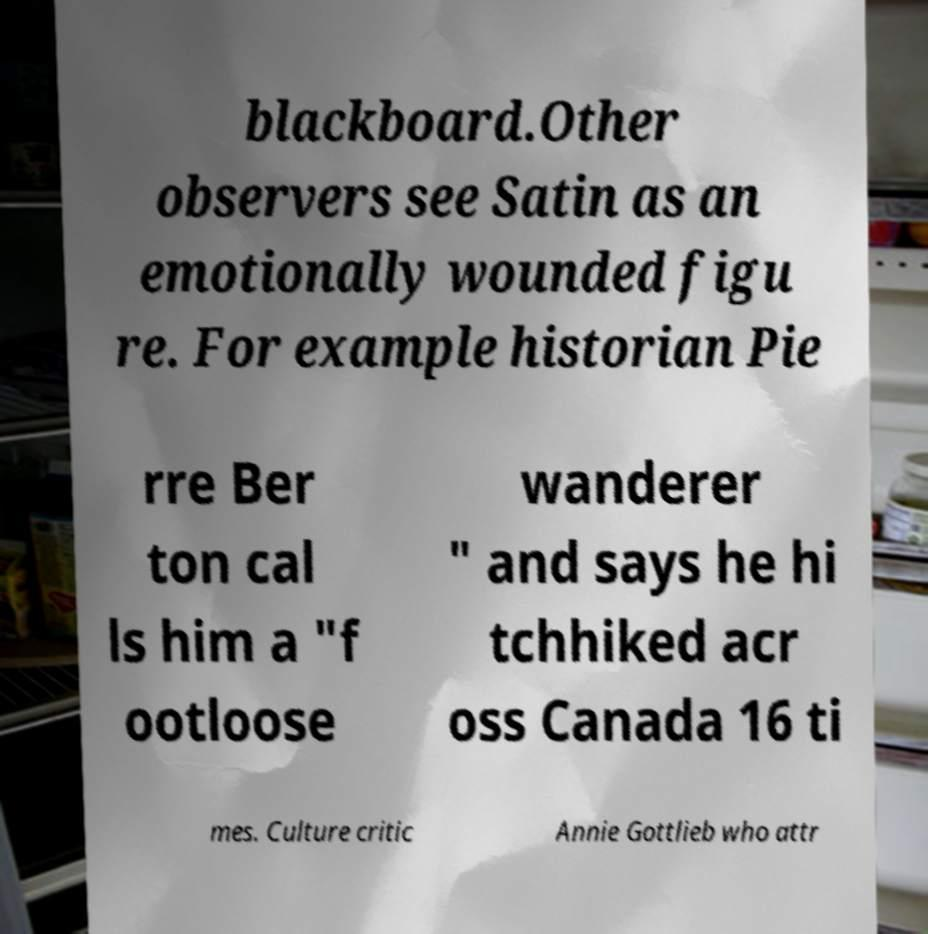Could you extract and type out the text from this image? blackboard.Other observers see Satin as an emotionally wounded figu re. For example historian Pie rre Ber ton cal ls him a "f ootloose wanderer " and says he hi tchhiked acr oss Canada 16 ti mes. Culture critic Annie Gottlieb who attr 